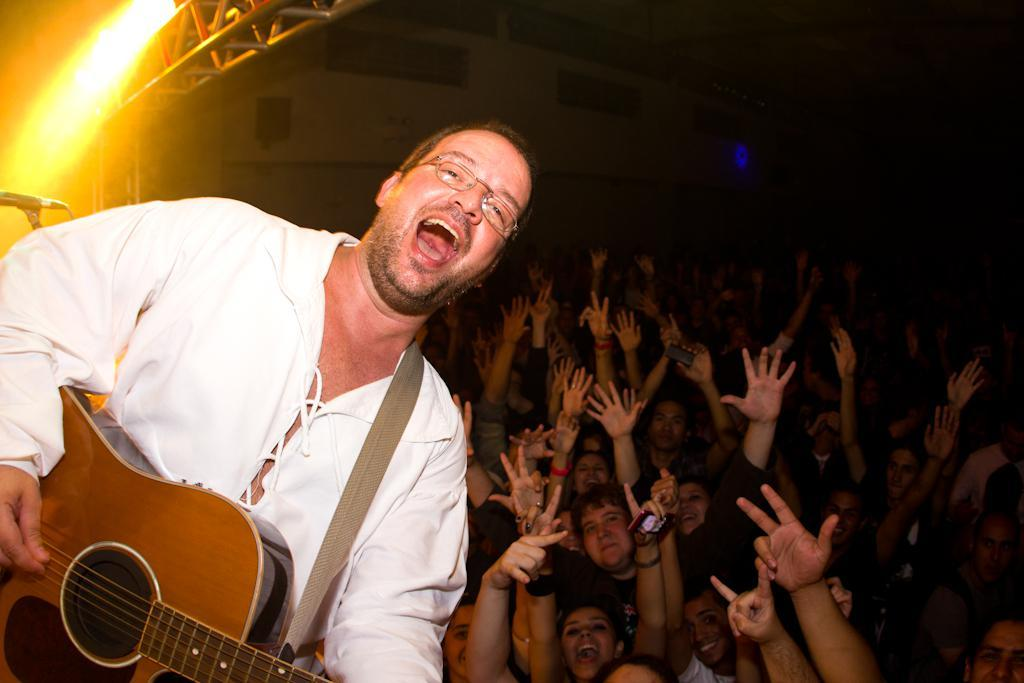What is happening in the image involving a group of people? There is a group of people in the image, and one person is playing a guitar. Can you describe the position of the person playing the guitar in relation to the group? The person playing the guitar is on the left side of the group. How does the person playing the guitar appear to feel? The person playing the guitar is smiling. How much money does the beggar collect from the group in the image? There is no beggar present in the image, so it is not possible to determine how much money they might collect. 